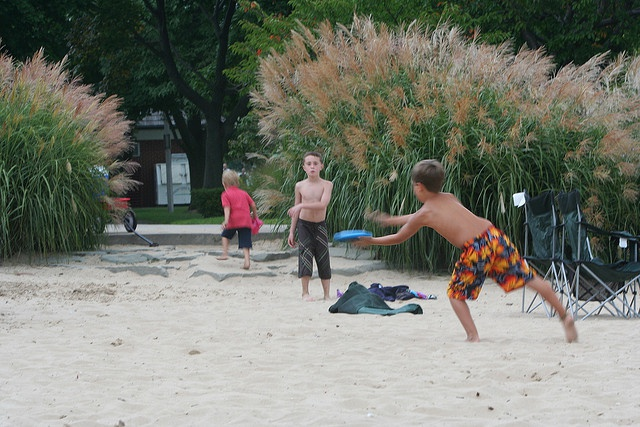Describe the objects in this image and their specific colors. I can see people in black and gray tones, chair in black, purple, lightgray, and darkgray tones, people in black, darkgray, and gray tones, chair in black, purple, gray, and darkgray tones, and people in black, brown, and darkgray tones in this image. 